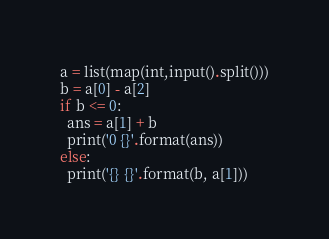<code> <loc_0><loc_0><loc_500><loc_500><_Python_>a = list(map(int,input().split()))
b = a[0] - a[2]
if b <= 0:
  ans = a[1] + b
  print('0 {}'.format(ans))
else:
  print('{} {}'.format(b, a[1]))
</code> 